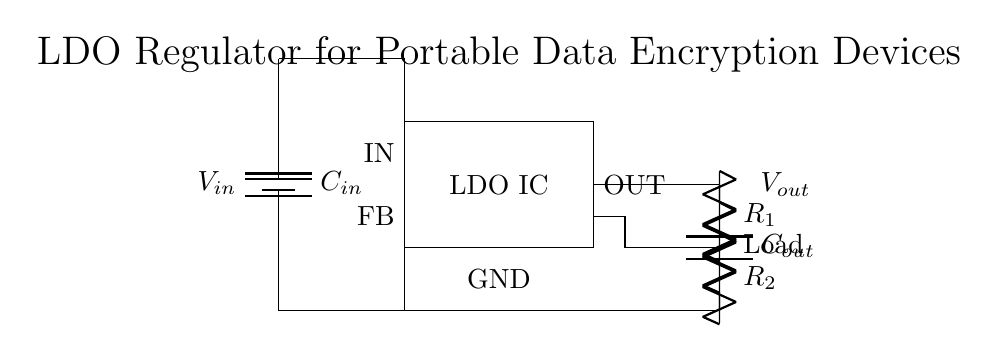What is the input voltage of the circuit? The input voltage is represented by V_in, which is connected to the battery symbol on the left side of the diagram.
Answer: V_in What components are used for feedback in this LDO circuit? The circuit has two resistors labeled R_1 and R_2 that are used for feedback, as indicated by their connections in the feedback loop.
Answer: R_1 and R_2 What is the role of the output capacitor in this circuit? The output capacitor labeled C_out is used to stabilize the output voltage by filtering noise and providing transient response support to the load.
Answer: Stabilization How many capacitors are present in the circuit? There are two capacitors shown in the circuit: C_in and C_out, as confirmed by their labels within the diagram.
Answer: Two What is the ground reference point for this circuit? The ground reference point is represented by the label GND at the bottom of the circuit, where all grounds converge.
Answer: GND What kind of load is connected to the output of the regulator? The load is represented as a resistor labeled Load, indicating that it is a resistive load connected to the output voltage.
Answer: Resistive load What is the primary purpose of this LDO regulator circuit? The main purpose of the LDO regulator circuit is to provide a stable output voltage lower than the input voltage suitable for powering portable data encryption devices.
Answer: Voltage regulation 